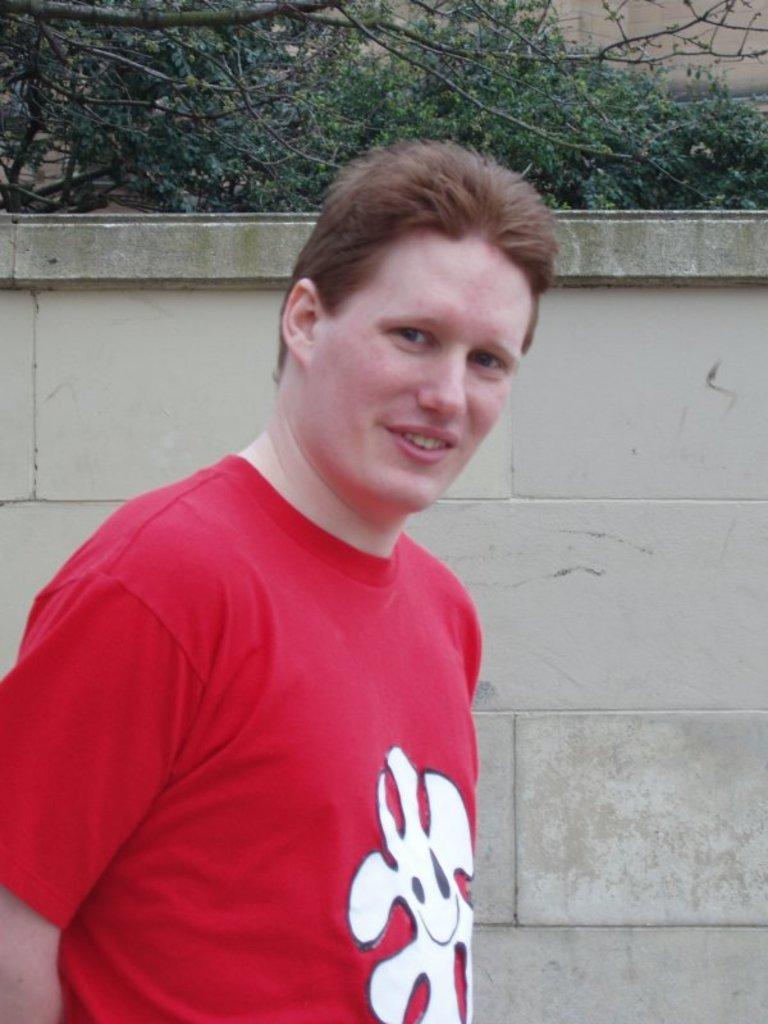Could you give a brief overview of what you see in this image? Here we can see a man is standing at the wall. In the background there are trees and wall. 